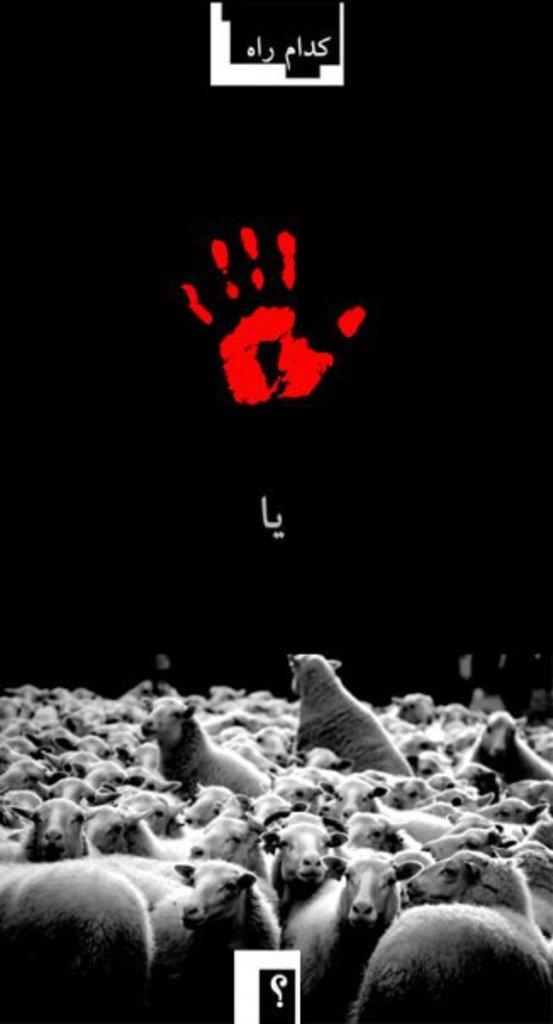What types of living organisms can be seen in the image? There are animals in the image. What is written or displayed at the top of the image? There is text at the top of the image. What mark or imprint can be seen in the image? There is a hand print in the image. What color is the background of the image? The background of the image is black. What is located at the bottom of the image? There is a symbol at the bottom of the image. How many ducks are sitting on the roof of the house in the image? There is no house or ducks present in the image. What type of crow is perched on the tree in the image? There is no tree or crow present in the image. 